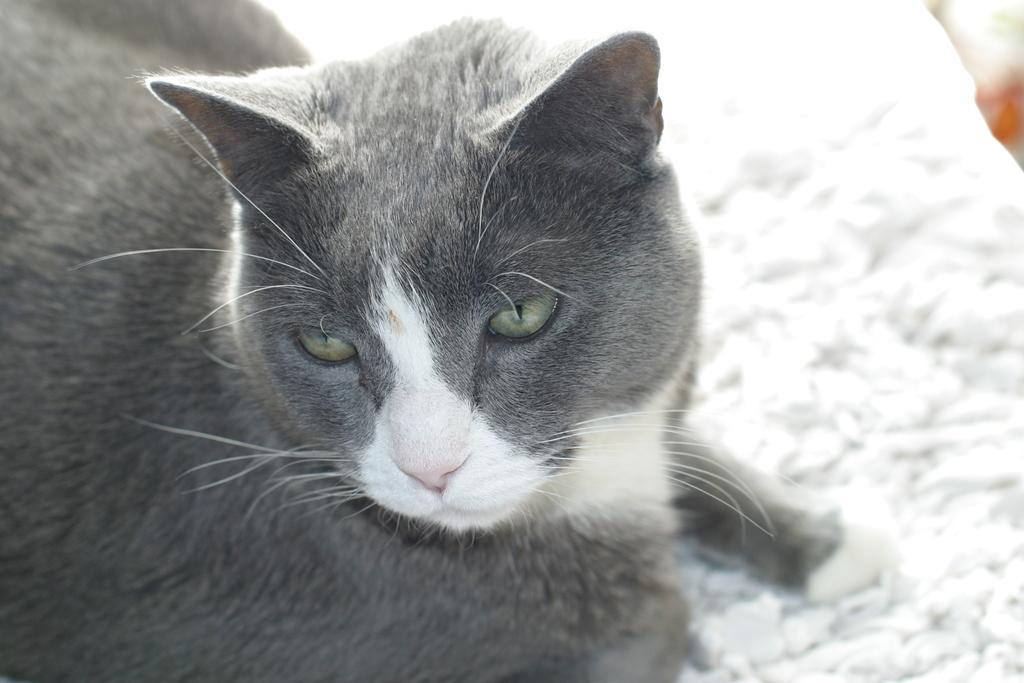Describe this image in one or two sentences. Here we can see a cat and there is a blur background. 